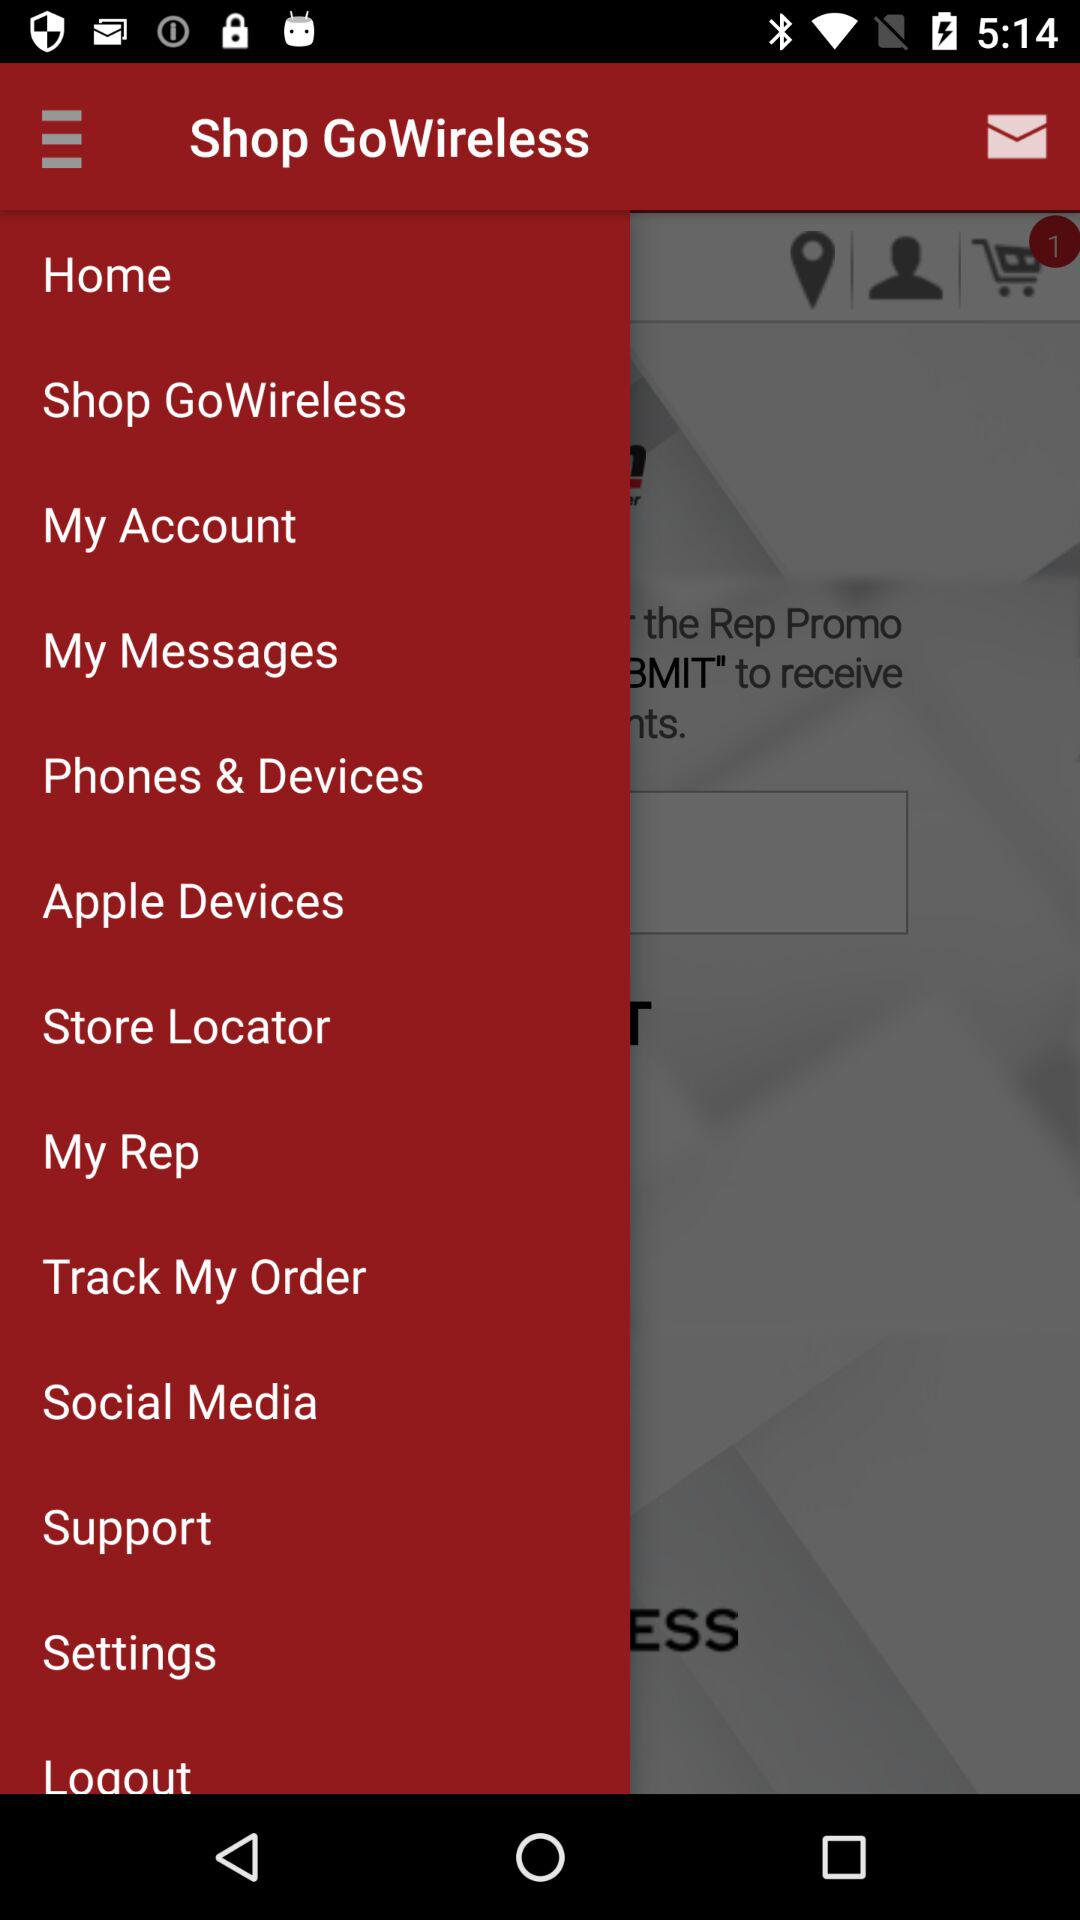What is the count of item in the cart? There is 1 item in the cart. 